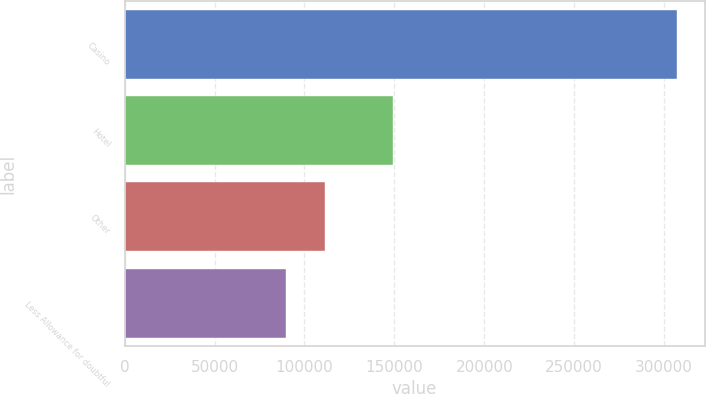Convert chart. <chart><loc_0><loc_0><loc_500><loc_500><bar_chart><fcel>Casino<fcel>Hotel<fcel>Other<fcel>Less Allowance for doubtful<nl><fcel>307152<fcel>149268<fcel>111357<fcel>89602<nl></chart> 